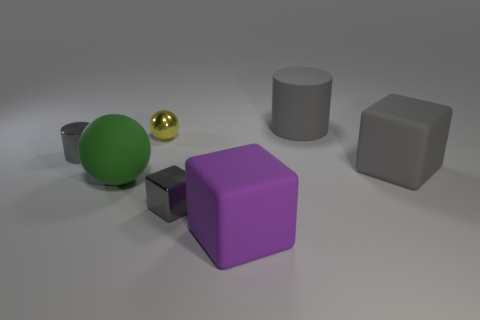Add 1 gray shiny objects. How many objects exist? 8 Subtract all large gray matte cubes. How many cubes are left? 2 Add 4 gray metal cylinders. How many gray metal cylinders are left? 5 Add 5 red matte cubes. How many red matte cubes exist? 5 Subtract all purple blocks. How many blocks are left? 2 Subtract 0 red spheres. How many objects are left? 7 Subtract all balls. How many objects are left? 5 Subtract 1 cylinders. How many cylinders are left? 1 Subtract all red balls. Subtract all green blocks. How many balls are left? 2 Subtract all purple cylinders. How many brown blocks are left? 0 